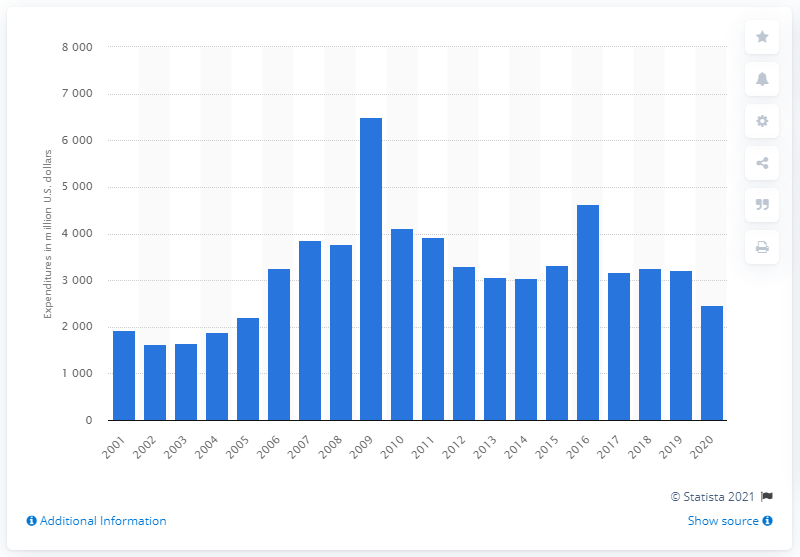When was the highest level of research and development expenditure?
 2016 